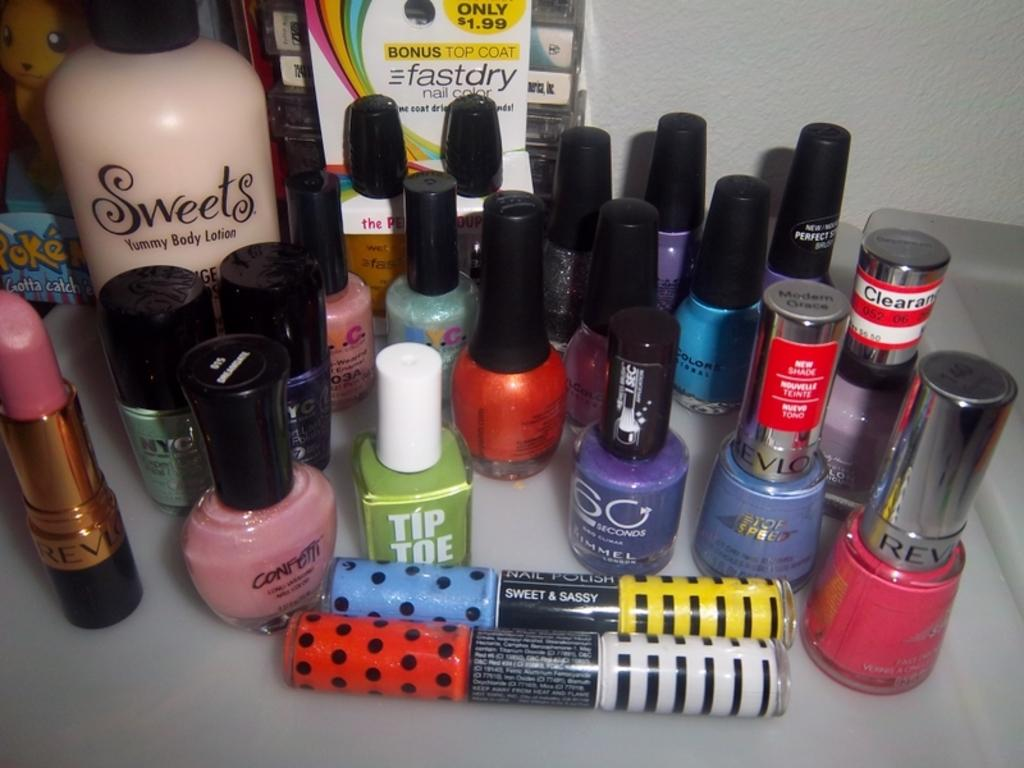<image>
Summarize the visual content of the image. A variety of nail polish with a Tip Toe green one in front 